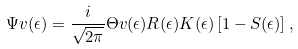Convert formula to latex. <formula><loc_0><loc_0><loc_500><loc_500>\Psi v ( \epsilon ) = \frac { i } { \sqrt { 2 \pi } } \Theta v ( \epsilon ) { R } ( \epsilon ) { K } ( \epsilon ) \left [ { 1 } - { S } ( \epsilon ) \right ] ,</formula> 